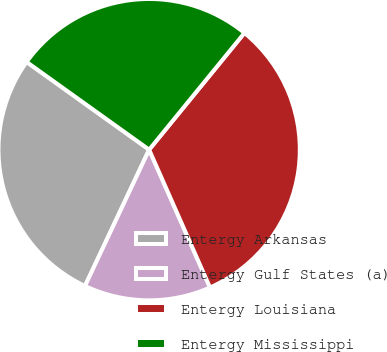<chart> <loc_0><loc_0><loc_500><loc_500><pie_chart><fcel>Entergy Arkansas<fcel>Entergy Gulf States (a)<fcel>Entergy Louisiana<fcel>Entergy Mississippi<nl><fcel>27.89%<fcel>13.62%<fcel>32.49%<fcel>26.01%<nl></chart> 